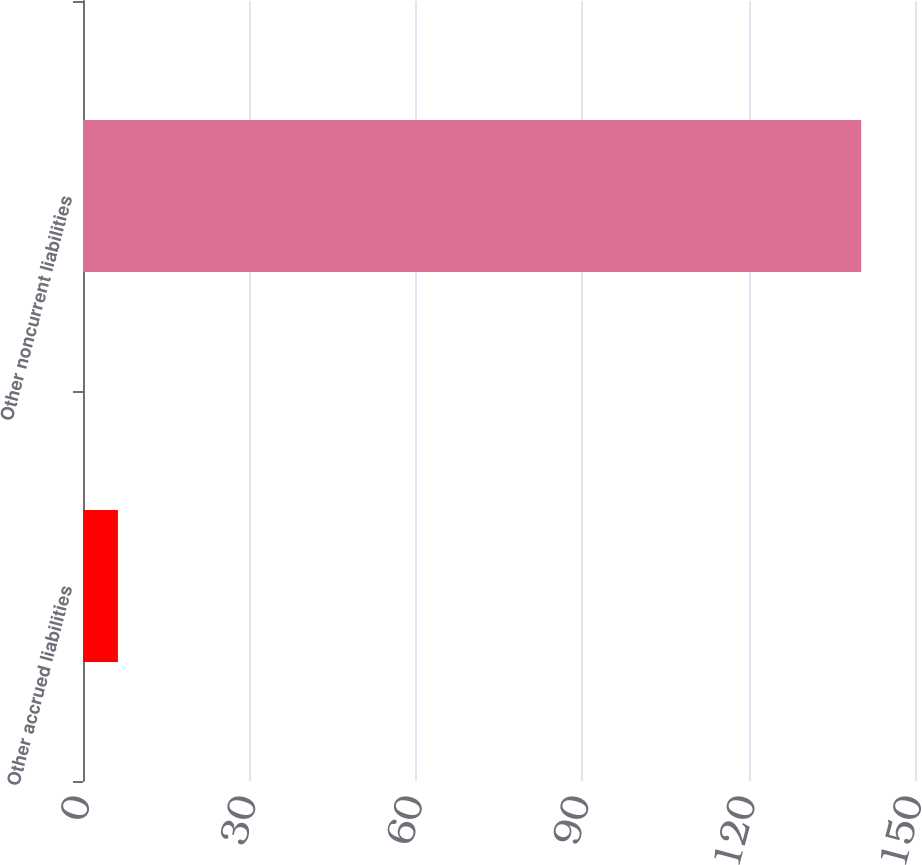<chart> <loc_0><loc_0><loc_500><loc_500><bar_chart><fcel>Other accrued liabilities<fcel>Other noncurrent liabilities<nl><fcel>6.3<fcel>140.3<nl></chart> 